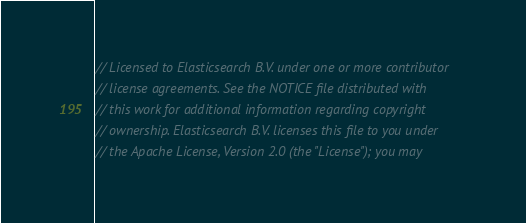Convert code to text. <code><loc_0><loc_0><loc_500><loc_500><_Go_>// Licensed to Elasticsearch B.V. under one or more contributor
// license agreements. See the NOTICE file distributed with
// this work for additional information regarding copyright
// ownership. Elasticsearch B.V. licenses this file to you under
// the Apache License, Version 2.0 (the "License"); you may</code> 